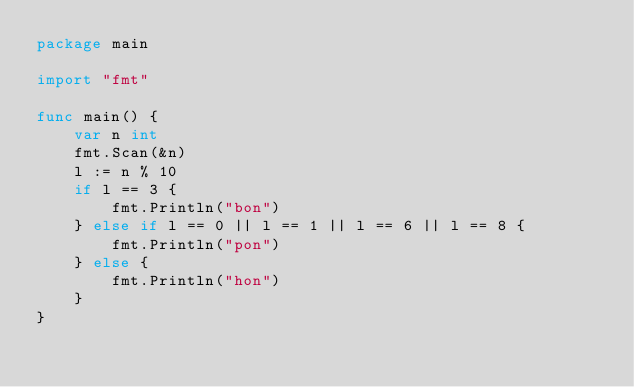<code> <loc_0><loc_0><loc_500><loc_500><_Go_>package main

import "fmt"

func main() {
	var n int
	fmt.Scan(&n)
	l := n % 10
	if l == 3 {
		fmt.Println("bon")
	} else if l == 0 || l == 1 || l == 6 || l == 8 {
		fmt.Println("pon")
	} else {
		fmt.Println("hon")
	}
}</code> 